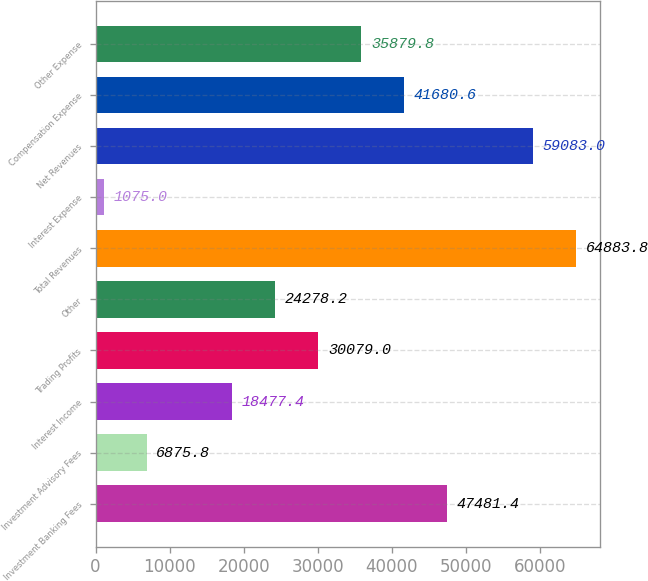<chart> <loc_0><loc_0><loc_500><loc_500><bar_chart><fcel>Investment Banking Fees<fcel>Investment Advisory Fees<fcel>Interest Income<fcel>Trading Profits<fcel>Other<fcel>Total Revenues<fcel>Interest Expense<fcel>Net Revenues<fcel>Compensation Expense<fcel>Other Expense<nl><fcel>47481.4<fcel>6875.8<fcel>18477.4<fcel>30079<fcel>24278.2<fcel>64883.8<fcel>1075<fcel>59083<fcel>41680.6<fcel>35879.8<nl></chart> 